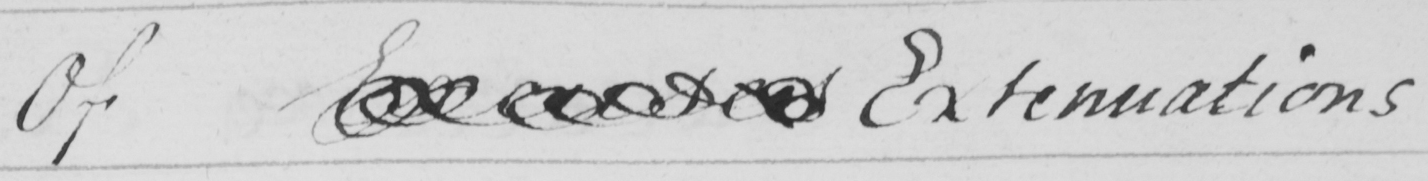Can you tell me what this handwritten text says? Of Excuses Extenuations 